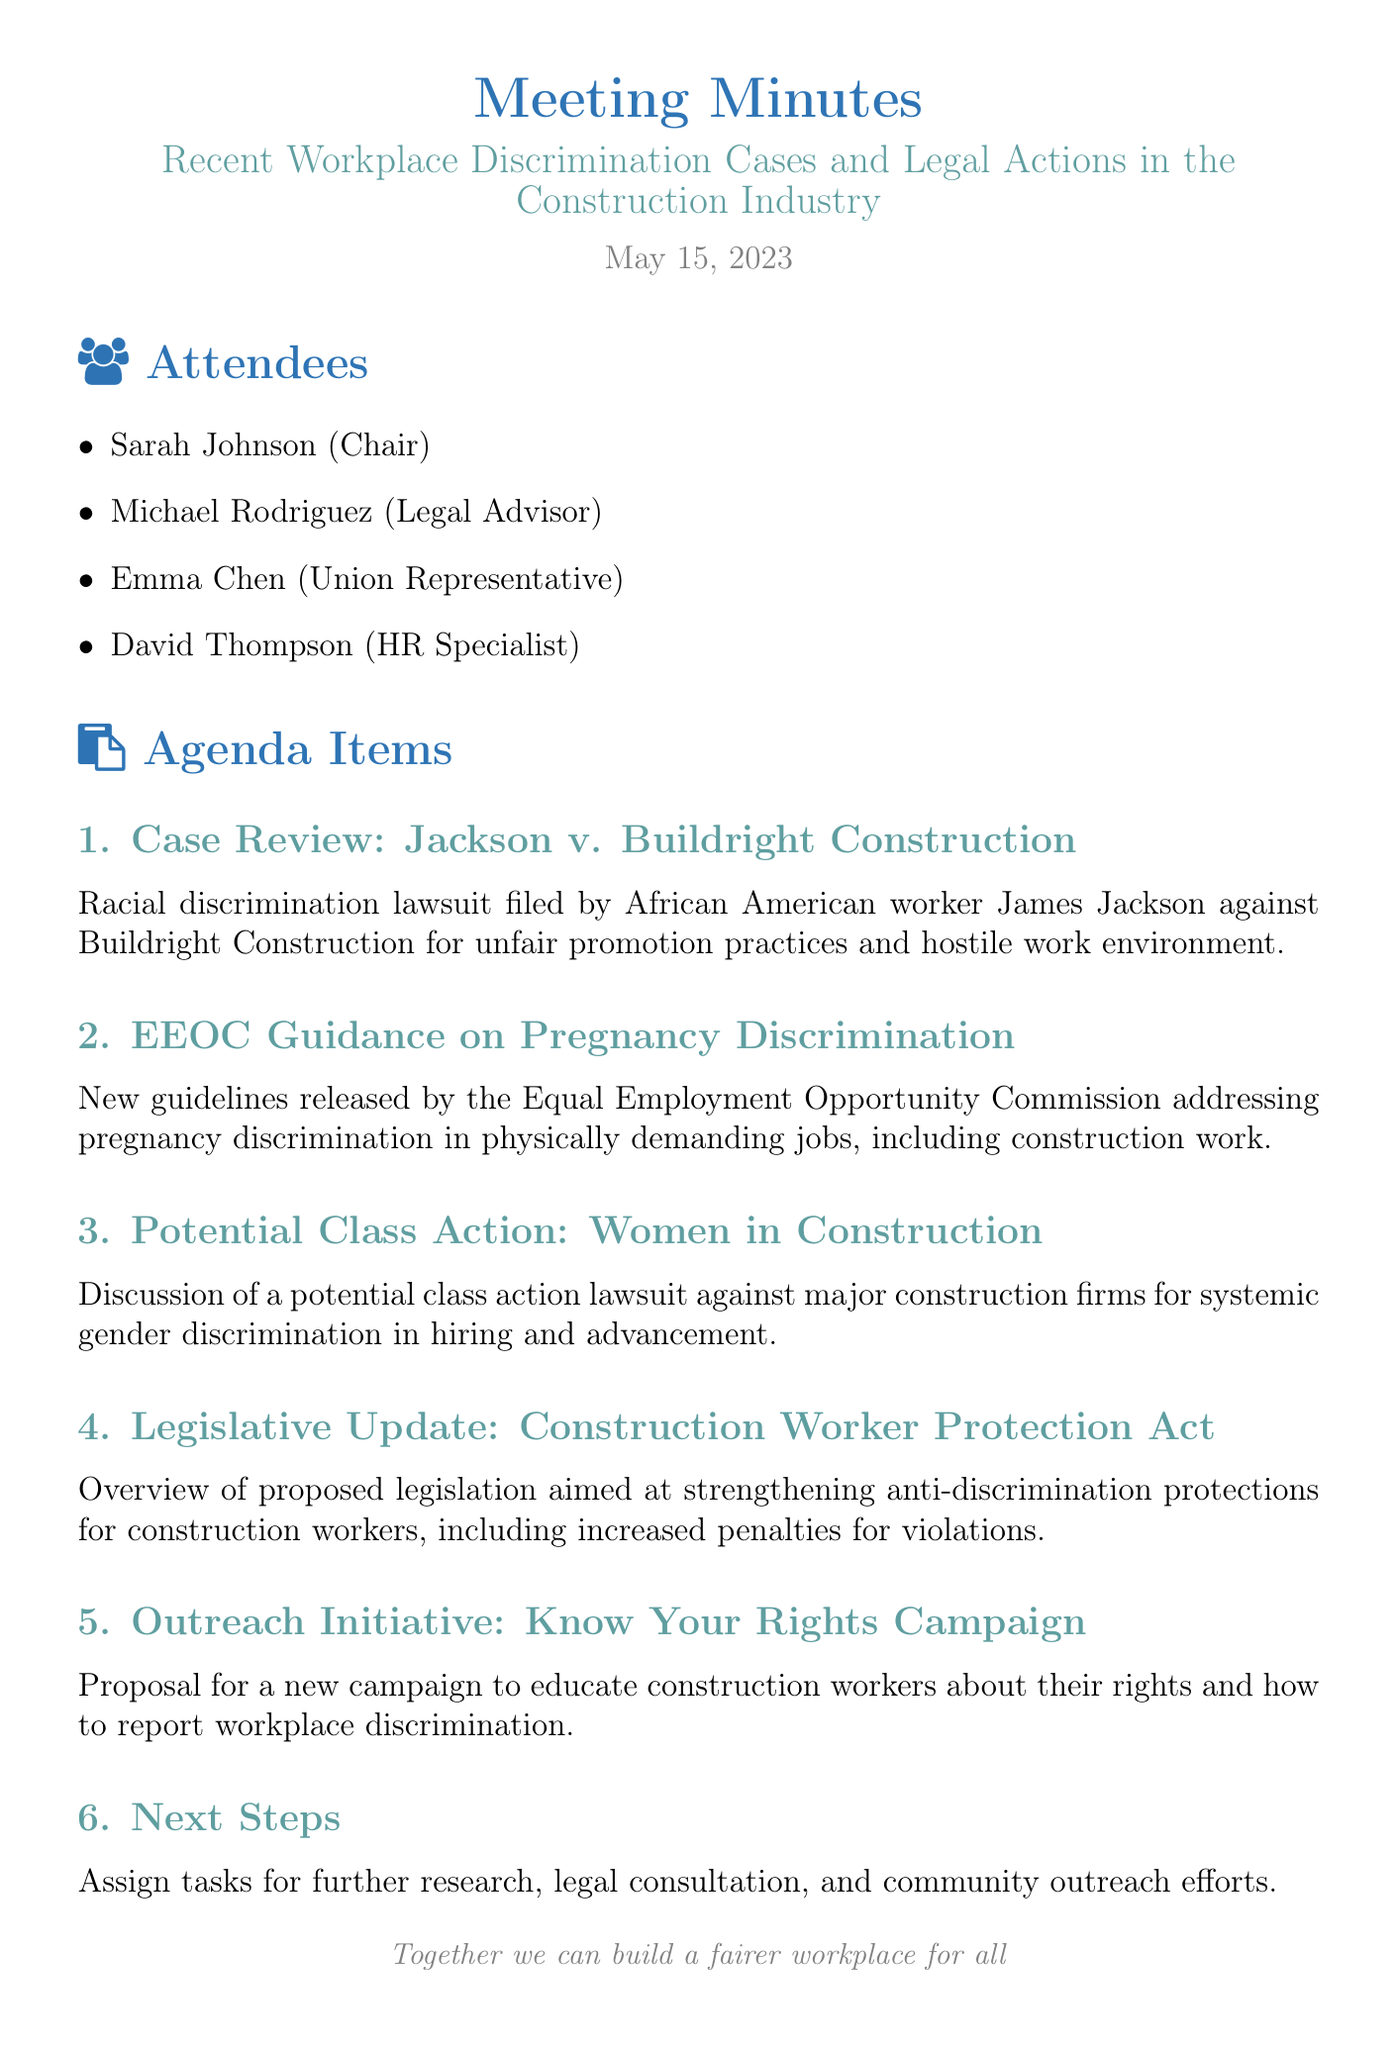What is the date of the meeting? The date of the meeting is mentioned at the top of the document.
Answer: May 15, 2023 Who is the union representative? The document lists attendees, and Emma Chen is identified as the union representative.
Answer: Emma Chen What case was reviewed regarding Buildright Construction? The document specifies the case discussed under the agenda item about racial discrimination.
Answer: Jackson v. Buildright Construction What guidelines did the EEOC release? The details on this agenda item clarify the topic regarding pregnancy discrimination.
Answer: Pregnancy discrimination What is the proposed legislation discussed in the meeting? The document contains an overview of a specific legislative proposal aimed at improving worker protections.
Answer: Construction Worker Protection Act What is the purpose of the Know Your Rights Campaign? The details in the agenda outline the goals of the outreach initiative discussed.
Answer: Educate construction workers about their rights How many agenda items were discussed? By counting the listed agenda items, we can identify the total number of them.
Answer: Six What is the main focus of the potential class action discussed? The agenda outlines the subject of this potential legal action based on systematic issues.
Answer: Systemic gender discrimination 